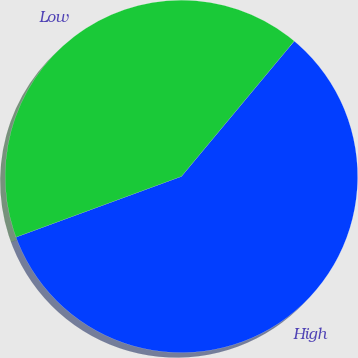Convert chart. <chart><loc_0><loc_0><loc_500><loc_500><pie_chart><fcel>High<fcel>Low<nl><fcel>58.34%<fcel>41.66%<nl></chart> 